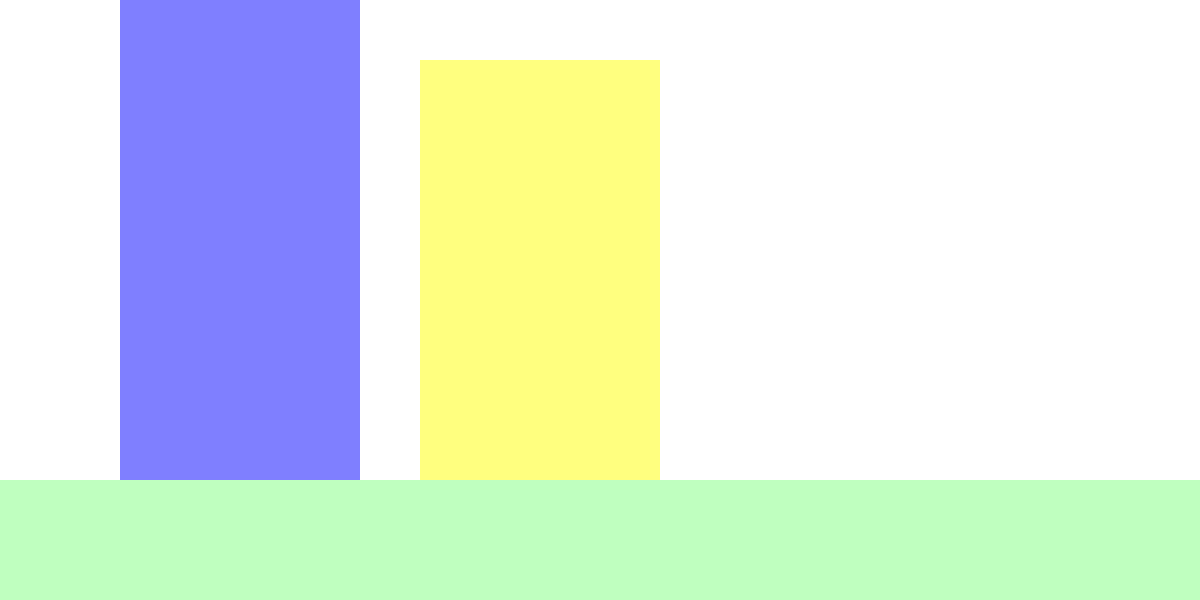In this quiet library setting, look at the shapes of the books on the shelf. How many sides does each book shape have? Let's count the sides of each book shape step-by-step:

1. Look at each book individually.
2. Start from one corner and trace the outline of the book.
3. Count each straight line as we go around the shape.

For each book:
- We start at the bottom-left corner.
- Move up (1st side)
- Move right (2nd side)
- Move down (3rd side)
- Move left back to where we started (4th side)

We see that this pattern is the same for all three books on the shelf.

Each book shape has 4 sides, forming a rectangle or square.
Answer: 4 sides 